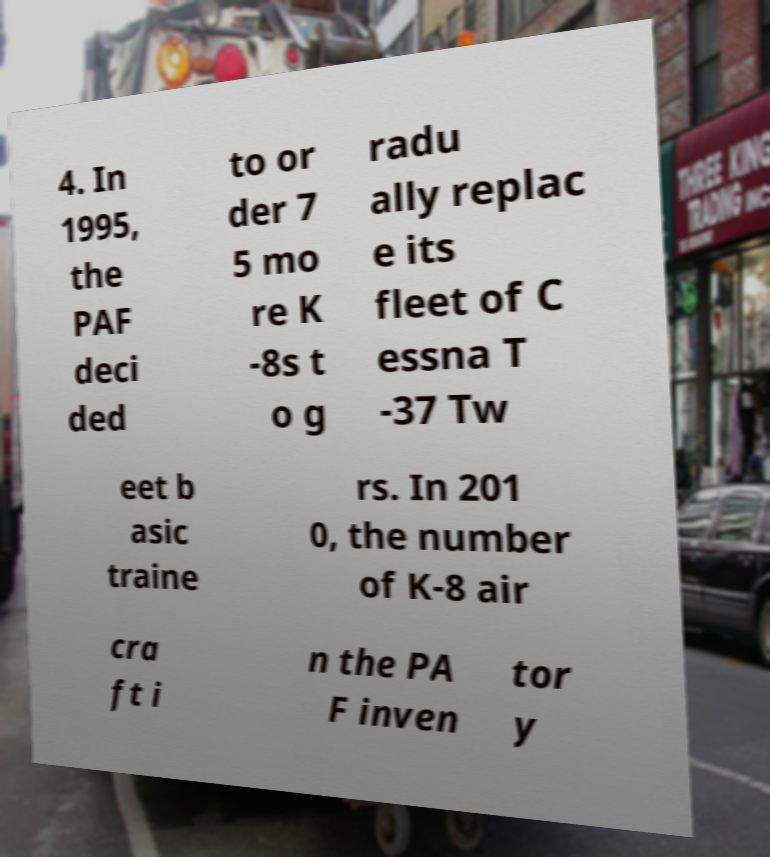Could you assist in decoding the text presented in this image and type it out clearly? 4. In 1995, the PAF deci ded to or der 7 5 mo re K -8s t o g radu ally replac e its fleet of C essna T -37 Tw eet b asic traine rs. In 201 0, the number of K-8 air cra ft i n the PA F inven tor y 